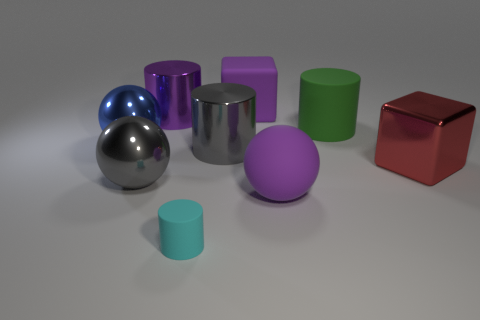What number of shiny objects are either purple cubes or big cyan cylinders?
Your answer should be compact. 0. What is the color of the other tiny object that is the same shape as the green object?
Ensure brevity in your answer.  Cyan. What number of large rubber objects are the same color as the tiny cylinder?
Your answer should be compact. 0. Is there a gray sphere in front of the purple thing that is in front of the big purple cylinder?
Your answer should be very brief. No. How many large things are on the left side of the tiny matte cylinder and in front of the green cylinder?
Your answer should be compact. 2. How many big purple things are made of the same material as the large purple ball?
Keep it short and to the point. 1. There is a gray object right of the metallic cylinder that is behind the large blue object; how big is it?
Offer a terse response. Large. Is there a small cyan shiny object that has the same shape as the blue metal thing?
Your answer should be compact. No. Do the metal thing that is in front of the red object and the cyan cylinder left of the red block have the same size?
Offer a very short reply. No. Is the number of cylinders that are to the left of the small cylinder less than the number of big metallic cubes left of the big red object?
Keep it short and to the point. No. 